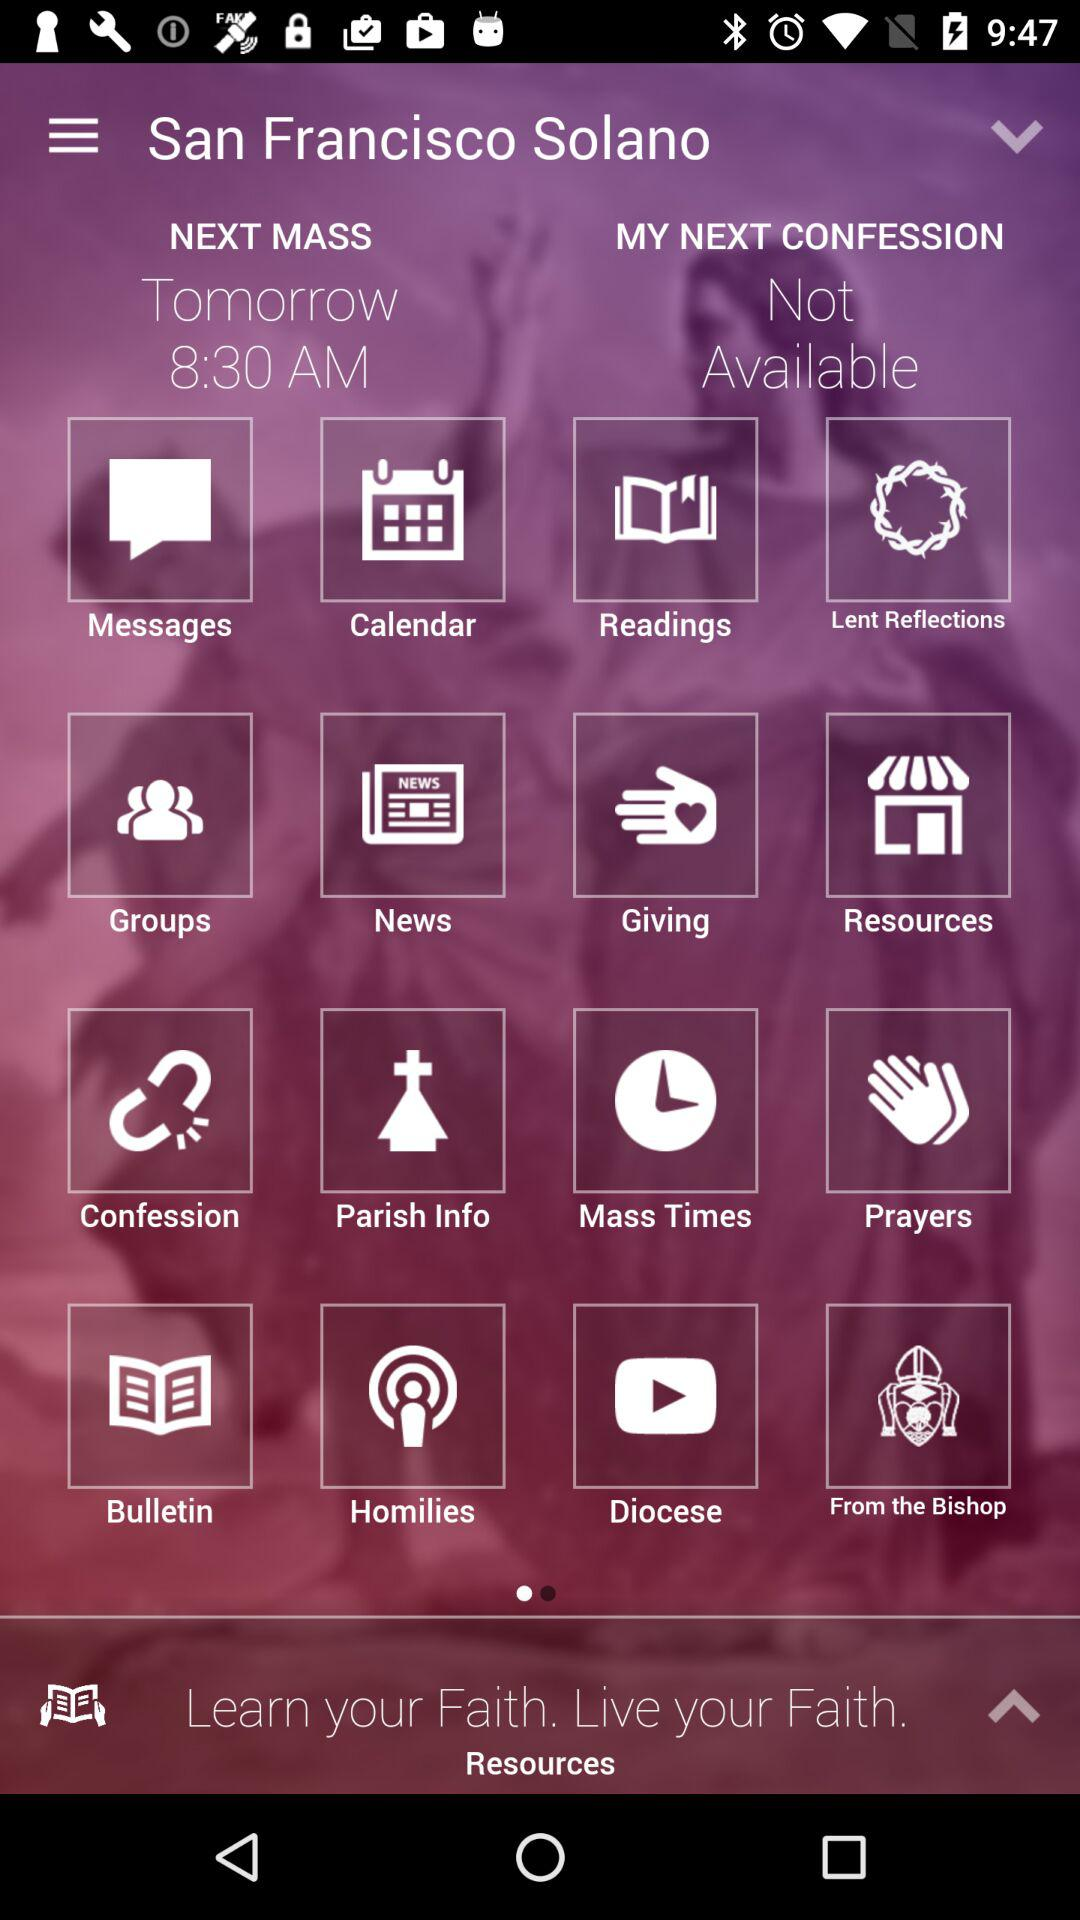What is the status of "MY NEXT CONFESSION"? The status is "Not Available". 